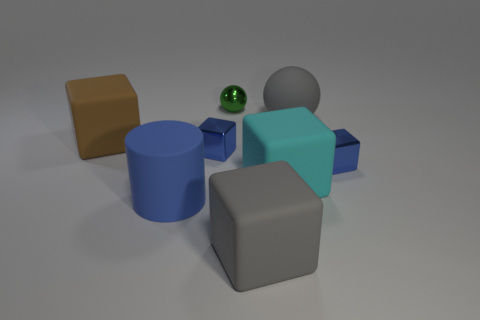There is a blue metal cube that is on the left side of the matte ball; are there any brown objects in front of it?
Keep it short and to the point. No. Does the small blue object that is left of the green metal object have the same shape as the cyan thing?
Provide a succinct answer. Yes. What shape is the big blue matte object?
Ensure brevity in your answer.  Cylinder. How many tiny cubes are the same material as the large cyan cube?
Offer a terse response. 0. Does the metallic ball have the same color as the big rubber thing that is behind the large brown rubber cube?
Provide a short and direct response. No. How many small cyan matte cylinders are there?
Provide a succinct answer. 0. Is there a big ball of the same color as the big cylinder?
Keep it short and to the point. No. The tiny metal object that is behind the large gray object behind the large rubber cube on the left side of the rubber cylinder is what color?
Offer a very short reply. Green. Is the gray ball made of the same material as the cyan thing in front of the big gray ball?
Your response must be concise. Yes. What is the small green thing made of?
Your response must be concise. Metal. 